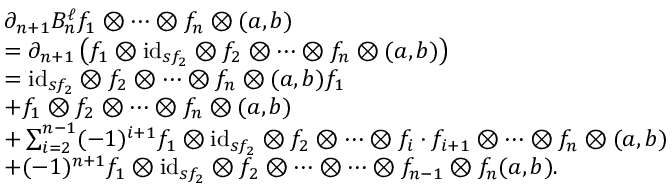Convert formula to latex. <formula><loc_0><loc_0><loc_500><loc_500>\begin{array} { r l } & { \partial _ { n + 1 } B _ { n } ^ { \ell } f _ { 1 } \otimes \dots \otimes f _ { n } \otimes ( a , b ) } \\ & { = \partial _ { n + 1 } \left ( f _ { 1 } \otimes i d _ { s f _ { 2 } } \otimes f _ { 2 } \otimes \dots \otimes f _ { n } \otimes ( a , b ) \right ) } \\ & { = i d _ { s f _ { 2 } } \otimes f _ { 2 } \otimes \dots \otimes f _ { n } \otimes ( a , b ) f _ { 1 } } \\ & { + f _ { 1 } \otimes f _ { 2 } \otimes \dots \otimes f _ { n } \otimes ( a , b ) } \\ & { + \sum _ { i = 2 } ^ { n - 1 } ( - 1 ) ^ { i + 1 } f _ { 1 } \otimes i d _ { s f _ { 2 } } \otimes f _ { 2 } \otimes \dots \otimes f _ { i } \cdot f _ { i + 1 } \otimes \dots \otimes f _ { n } \otimes ( a , b ) } \\ & { + ( - 1 ) ^ { n + 1 } f _ { 1 } \otimes i d _ { s f _ { 2 } } \otimes f _ { 2 } \otimes \dots \otimes \dots \otimes f _ { n - 1 } \otimes f _ { n } ( a , b ) . } \end{array}</formula> 